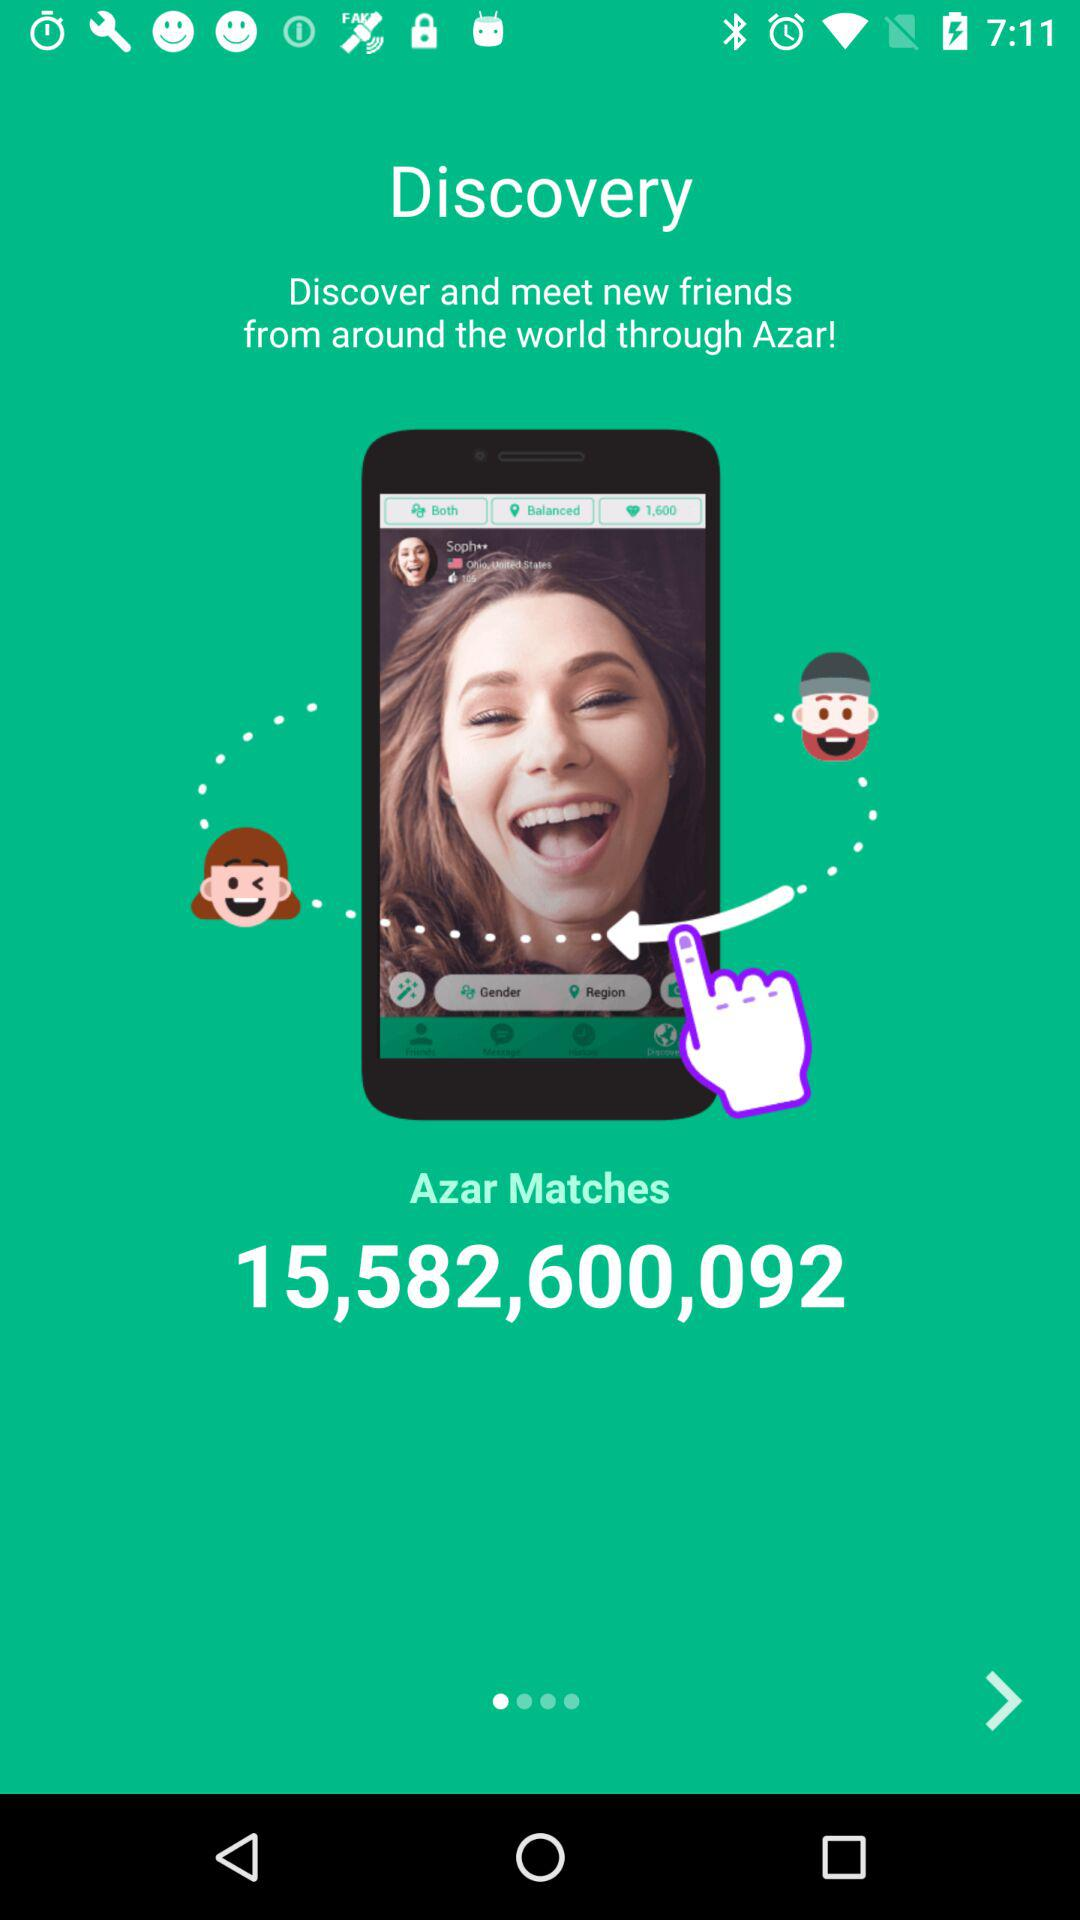What is the application name? The application name is "Azar". 